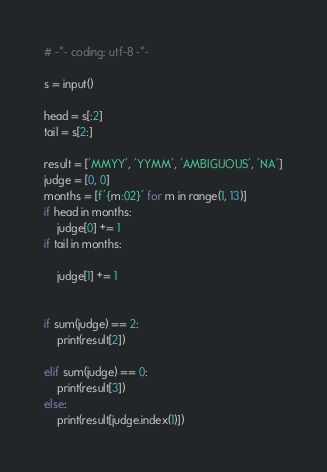Convert code to text. <code><loc_0><loc_0><loc_500><loc_500><_Python_># -*- coding: utf-8 -*-

s = input()

head = s[:2]
tail = s[2:]

result = ['MMYY', 'YYMM', 'AMBIGUOUS', 'NA']
judge = [0, 0]
months = [f'{m:02}' for m in range(1, 13)]
if head in months:
    judge[0] += 1
if tail in months:

    judge[1] += 1


if sum(judge) == 2:
    print(result[2])

elif sum(judge) == 0:
    print(result[3])
else:
    print(result[judge.index(1)])
</code> 